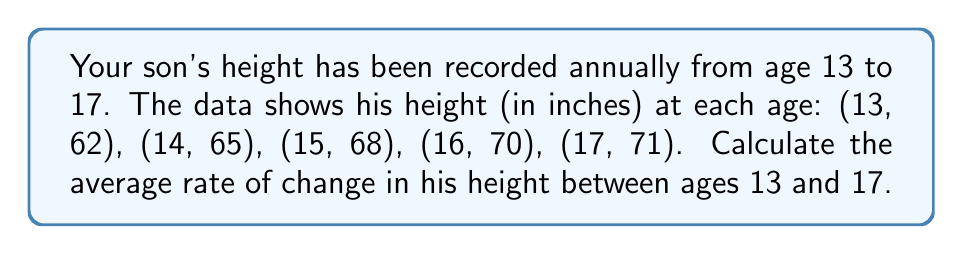Provide a solution to this math problem. To calculate the average rate of change in height between ages 13 and 17, we need to use the formula:

$$\text{Average rate of change} = \frac{\text{Change in height}}{\text{Change in time}}$$

Let's break this down step-by-step:

1) First, let's identify our initial and final points:
   Initial point: (13, 62)
   Final point: (17, 71)

2) Now, let's calculate the change in height:
   $$\Delta \text{height} = 71 - 62 = 9 \text{ inches}$$

3) Next, let's calculate the change in time:
   $$\Delta \text{time} = 17 - 13 = 4 \text{ years}$$

4) Now we can plug these values into our formula:

   $$\text{Average rate of change} = \frac{9 \text{ inches}}{4 \text{ years}} = 2.25 \text{ inches per year}$$

This means that, on average, your son's height increased by 2.25 inches each year between ages 13 and 17.
Answer: The average rate of change in height is $2.25 \text{ inches per year}$. 